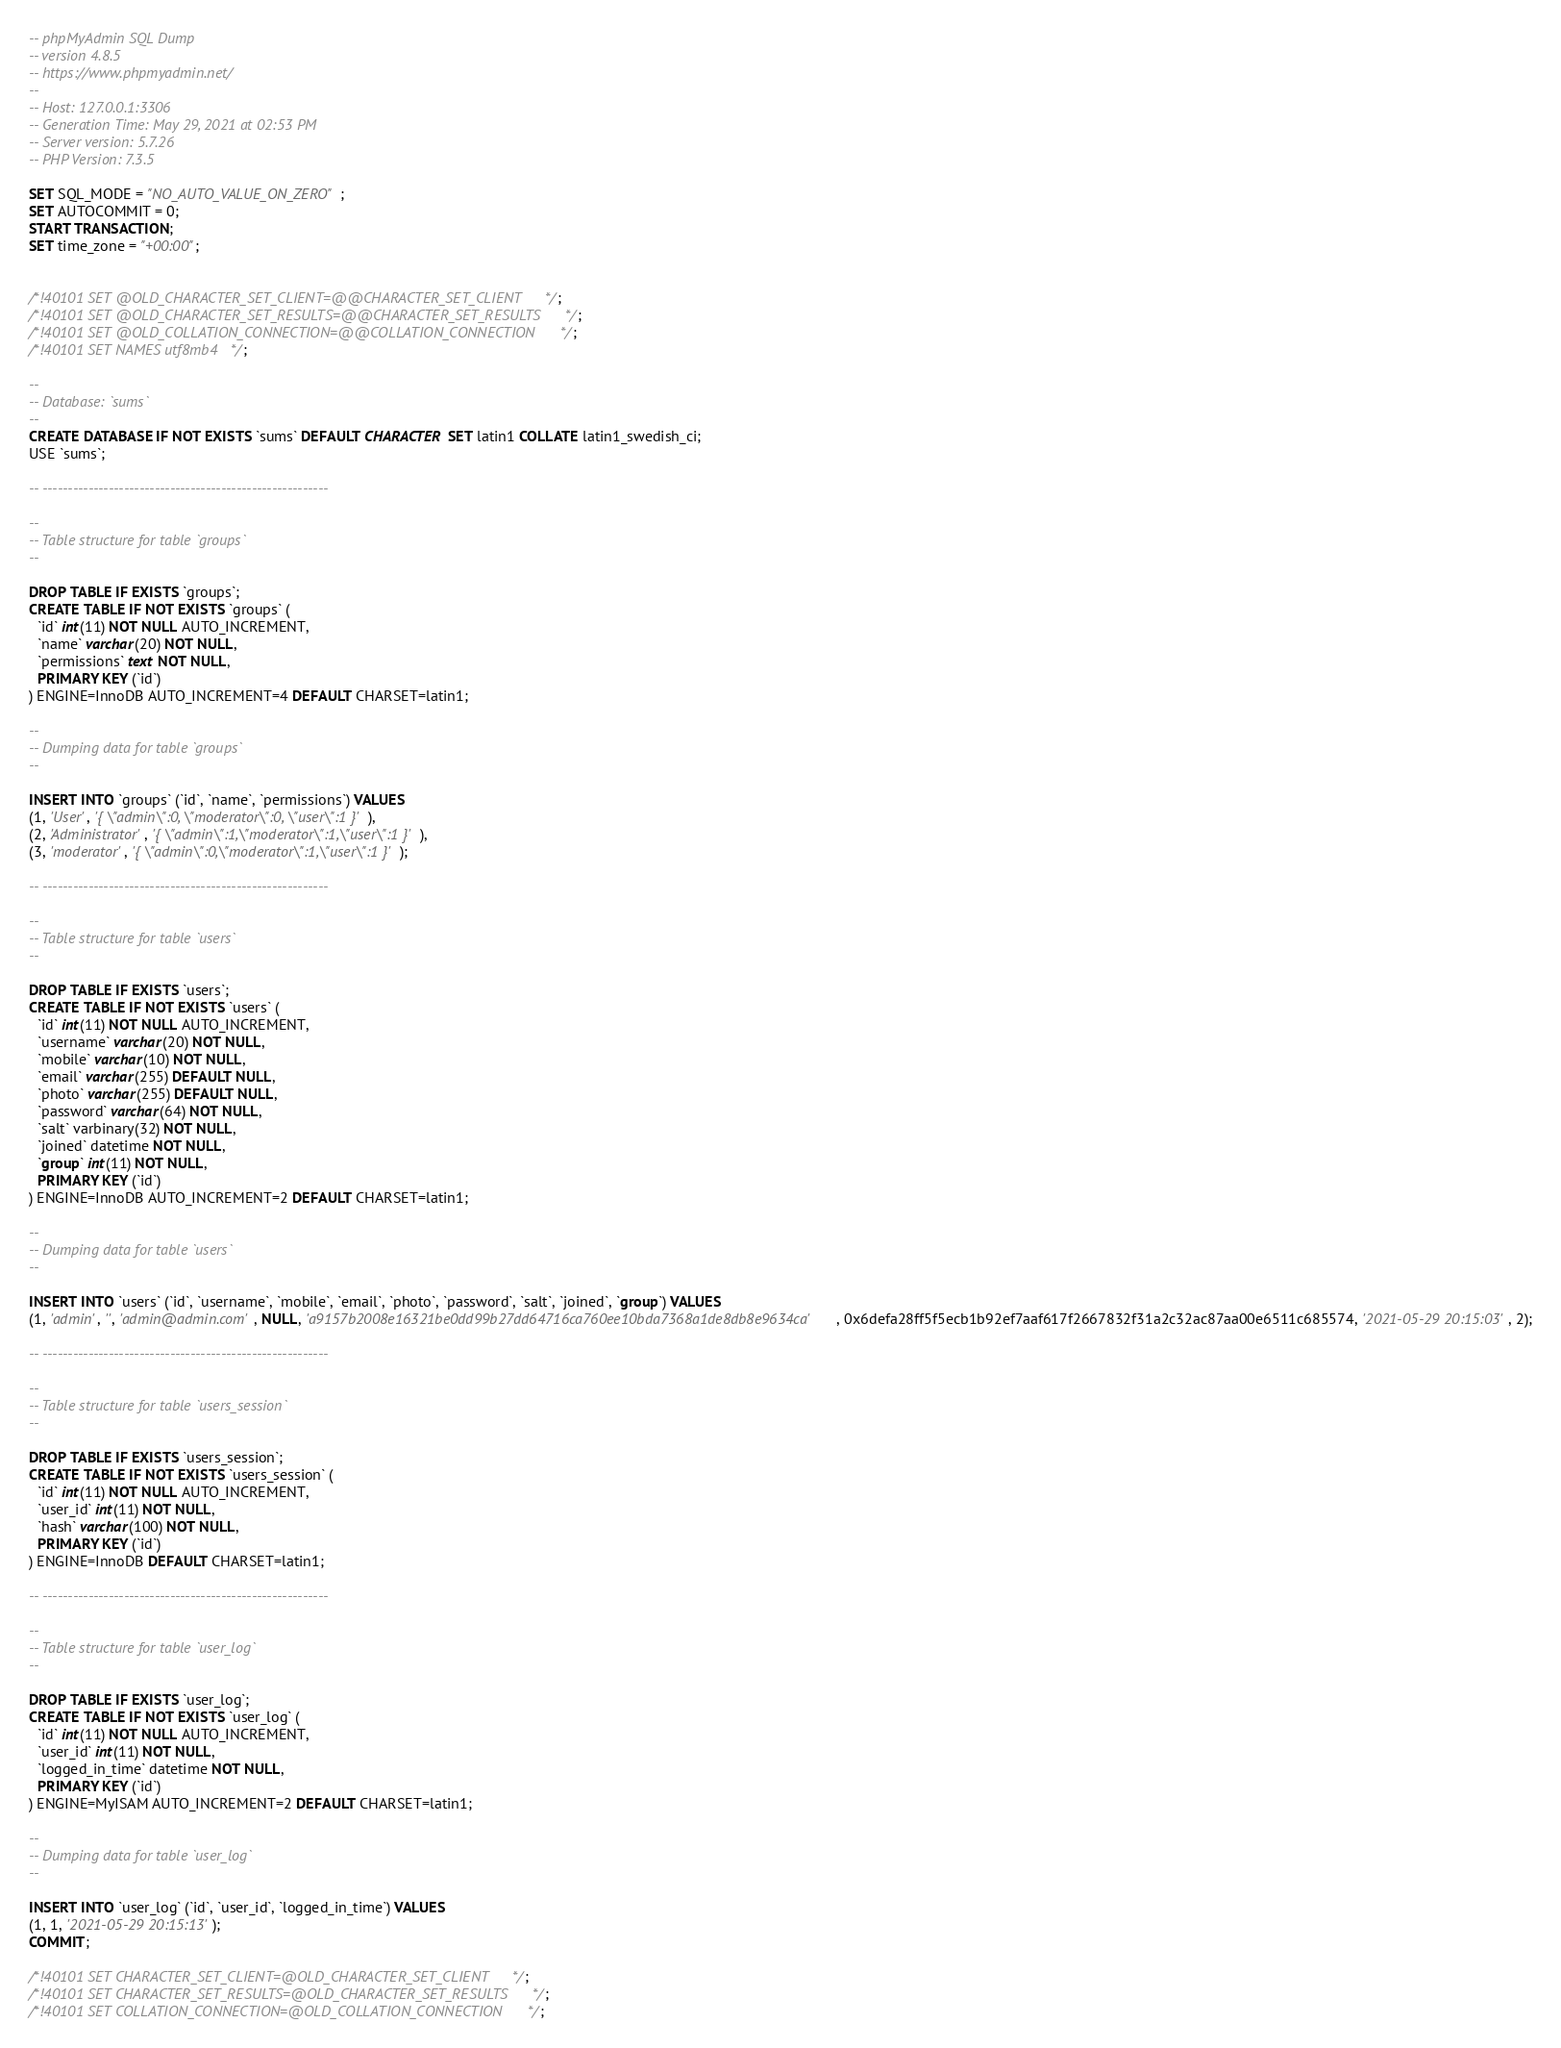Convert code to text. <code><loc_0><loc_0><loc_500><loc_500><_SQL_>-- phpMyAdmin SQL Dump
-- version 4.8.5
-- https://www.phpmyadmin.net/
--
-- Host: 127.0.0.1:3306
-- Generation Time: May 29, 2021 at 02:53 PM
-- Server version: 5.7.26
-- PHP Version: 7.3.5

SET SQL_MODE = "NO_AUTO_VALUE_ON_ZERO";
SET AUTOCOMMIT = 0;
START TRANSACTION;
SET time_zone = "+00:00";


/*!40101 SET @OLD_CHARACTER_SET_CLIENT=@@CHARACTER_SET_CLIENT */;
/*!40101 SET @OLD_CHARACTER_SET_RESULTS=@@CHARACTER_SET_RESULTS */;
/*!40101 SET @OLD_COLLATION_CONNECTION=@@COLLATION_CONNECTION */;
/*!40101 SET NAMES utf8mb4 */;

--
-- Database: `sums`
--
CREATE DATABASE IF NOT EXISTS `sums` DEFAULT CHARACTER SET latin1 COLLATE latin1_swedish_ci;
USE `sums`;

-- --------------------------------------------------------

--
-- Table structure for table `groups`
--

DROP TABLE IF EXISTS `groups`;
CREATE TABLE IF NOT EXISTS `groups` (
  `id` int(11) NOT NULL AUTO_INCREMENT,
  `name` varchar(20) NOT NULL,
  `permissions` text NOT NULL,
  PRIMARY KEY (`id`)
) ENGINE=InnoDB AUTO_INCREMENT=4 DEFAULT CHARSET=latin1;

--
-- Dumping data for table `groups`
--

INSERT INTO `groups` (`id`, `name`, `permissions`) VALUES
(1, 'User', '{ \"admin\":0, \"moderator\":0, \"user\":1 }'),
(2, 'Administrator', '{ \"admin\":1,\"moderator\":1,\"user\":1 }'),
(3, 'moderator', '{ \"admin\":0,\"moderator\":1,\"user\":1 }');

-- --------------------------------------------------------

--
-- Table structure for table `users`
--

DROP TABLE IF EXISTS `users`;
CREATE TABLE IF NOT EXISTS `users` (
  `id` int(11) NOT NULL AUTO_INCREMENT,
  `username` varchar(20) NOT NULL,
  `mobile` varchar(10) NOT NULL,
  `email` varchar(255) DEFAULT NULL,
  `photo` varchar(255) DEFAULT NULL,
  `password` varchar(64) NOT NULL,
  `salt` varbinary(32) NOT NULL,
  `joined` datetime NOT NULL,
  `group` int(11) NOT NULL,
  PRIMARY KEY (`id`)
) ENGINE=InnoDB AUTO_INCREMENT=2 DEFAULT CHARSET=latin1;

--
-- Dumping data for table `users`
--

INSERT INTO `users` (`id`, `username`, `mobile`, `email`, `photo`, `password`, `salt`, `joined`, `group`) VALUES
(1, 'admin', '', 'admin@admin.com', NULL, 'a9157b2008e16321be0dd99b27dd64716ca760ee10bda7368a1de8db8e9634ca', 0x6defa28ff5f5ecb1b92ef7aaf617f2667832f31a2c32ac87aa00e6511c685574, '2021-05-29 20:15:03', 2);

-- --------------------------------------------------------

--
-- Table structure for table `users_session`
--

DROP TABLE IF EXISTS `users_session`;
CREATE TABLE IF NOT EXISTS `users_session` (
  `id` int(11) NOT NULL AUTO_INCREMENT,
  `user_id` int(11) NOT NULL,
  `hash` varchar(100) NOT NULL,
  PRIMARY KEY (`id`)
) ENGINE=InnoDB DEFAULT CHARSET=latin1;

-- --------------------------------------------------------

--
-- Table structure for table `user_log`
--

DROP TABLE IF EXISTS `user_log`;
CREATE TABLE IF NOT EXISTS `user_log` (
  `id` int(11) NOT NULL AUTO_INCREMENT,
  `user_id` int(11) NOT NULL,
  `logged_in_time` datetime NOT NULL,
  PRIMARY KEY (`id`)
) ENGINE=MyISAM AUTO_INCREMENT=2 DEFAULT CHARSET=latin1;

--
-- Dumping data for table `user_log`
--

INSERT INTO `user_log` (`id`, `user_id`, `logged_in_time`) VALUES
(1, 1, '2021-05-29 20:15:13');
COMMIT;

/*!40101 SET CHARACTER_SET_CLIENT=@OLD_CHARACTER_SET_CLIENT */;
/*!40101 SET CHARACTER_SET_RESULTS=@OLD_CHARACTER_SET_RESULTS */;
/*!40101 SET COLLATION_CONNECTION=@OLD_COLLATION_CONNECTION */;
</code> 